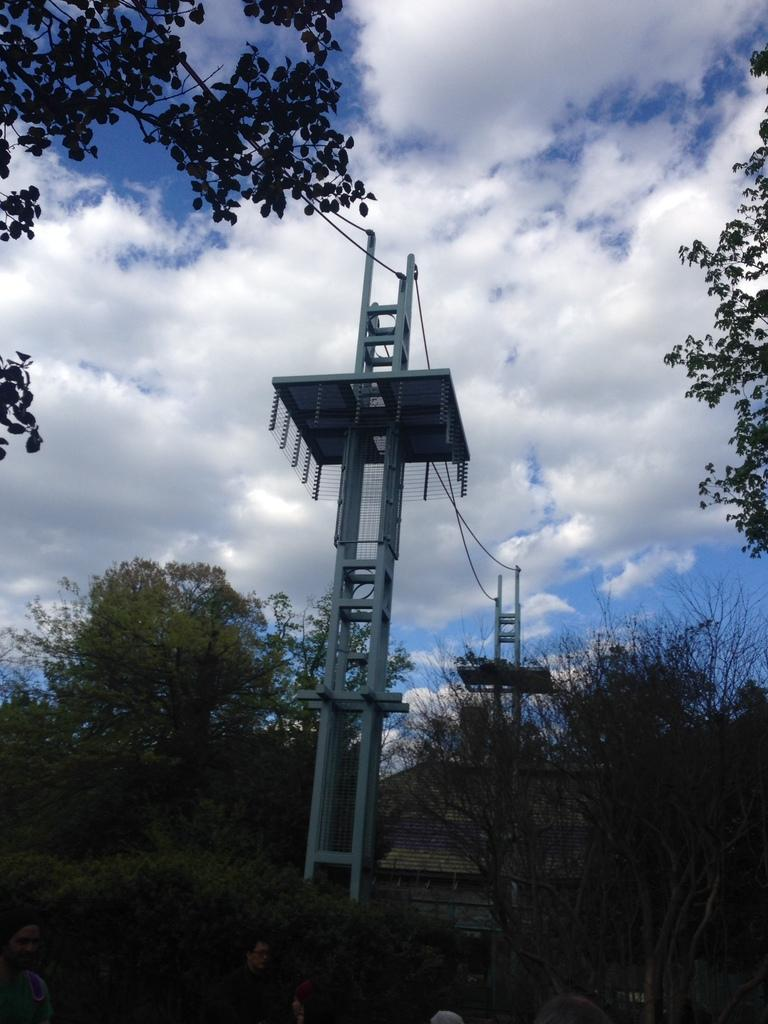What structures can be seen in the image? There are poles and wires in the image. What type of natural elements are present in the image? There are trees in the image. What can be seen in the background of the image? The sky is blue in the background, and there are clouds in the sky. What type of mask is being discussed in the image? There is no mask or discussion present in the image; it features poles, wires, trees, and a blue sky with clouds. What type of educational material is visible in the image? There is no educational material present in the image. 